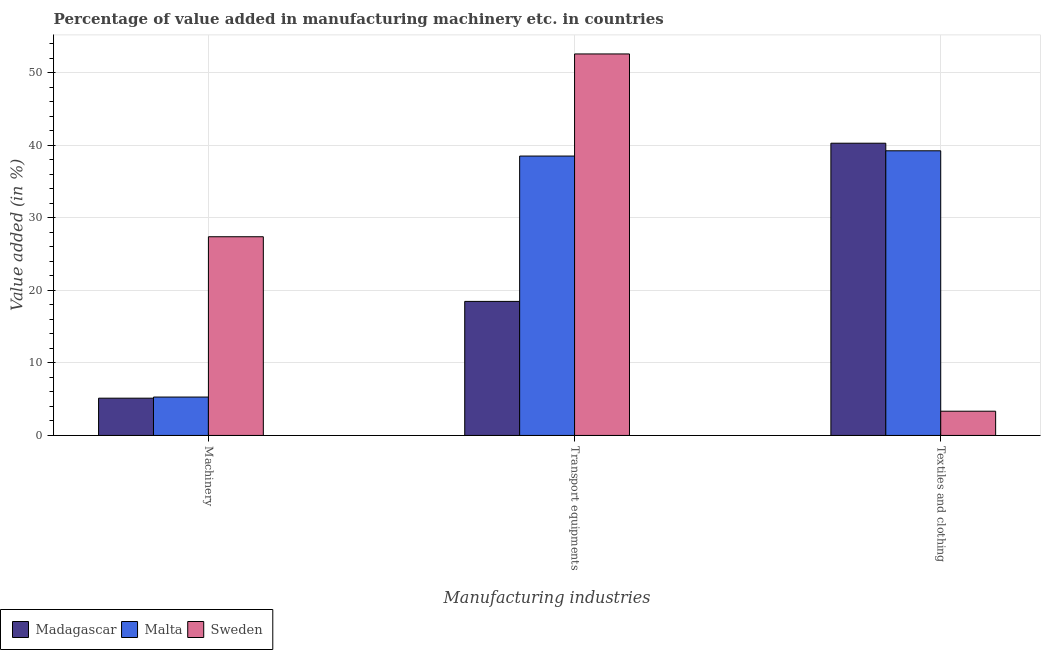How many different coloured bars are there?
Ensure brevity in your answer.  3. Are the number of bars on each tick of the X-axis equal?
Your response must be concise. Yes. How many bars are there on the 3rd tick from the left?
Give a very brief answer. 3. How many bars are there on the 3rd tick from the right?
Provide a succinct answer. 3. What is the label of the 3rd group of bars from the left?
Keep it short and to the point. Textiles and clothing. What is the value added in manufacturing transport equipments in Malta?
Provide a succinct answer. 38.49. Across all countries, what is the maximum value added in manufacturing textile and clothing?
Offer a terse response. 40.26. Across all countries, what is the minimum value added in manufacturing textile and clothing?
Your response must be concise. 3.34. In which country was the value added in manufacturing machinery minimum?
Your answer should be compact. Madagascar. What is the total value added in manufacturing transport equipments in the graph?
Your answer should be very brief. 109.52. What is the difference between the value added in manufacturing textile and clothing in Madagascar and that in Malta?
Your answer should be compact. 1.04. What is the difference between the value added in manufacturing textile and clothing in Sweden and the value added in manufacturing transport equipments in Madagascar?
Provide a succinct answer. -15.13. What is the average value added in manufacturing textile and clothing per country?
Make the answer very short. 27.61. What is the difference between the value added in manufacturing machinery and value added in manufacturing transport equipments in Sweden?
Keep it short and to the point. -25.18. In how many countries, is the value added in manufacturing textile and clothing greater than 8 %?
Your response must be concise. 2. What is the ratio of the value added in manufacturing textile and clothing in Sweden to that in Madagascar?
Keep it short and to the point. 0.08. What is the difference between the highest and the second highest value added in manufacturing machinery?
Make the answer very short. 22.09. What is the difference between the highest and the lowest value added in manufacturing machinery?
Ensure brevity in your answer.  22.24. In how many countries, is the value added in manufacturing transport equipments greater than the average value added in manufacturing transport equipments taken over all countries?
Offer a very short reply. 2. Is the sum of the value added in manufacturing machinery in Sweden and Malta greater than the maximum value added in manufacturing transport equipments across all countries?
Keep it short and to the point. No. What does the 2nd bar from the left in Machinery represents?
Offer a terse response. Malta. What does the 1st bar from the right in Transport equipments represents?
Provide a succinct answer. Sweden. How many bars are there?
Keep it short and to the point. 9. Are all the bars in the graph horizontal?
Give a very brief answer. No. How many countries are there in the graph?
Make the answer very short. 3. Are the values on the major ticks of Y-axis written in scientific E-notation?
Ensure brevity in your answer.  No. Does the graph contain any zero values?
Offer a terse response. No. Does the graph contain grids?
Make the answer very short. Yes. How many legend labels are there?
Your response must be concise. 3. What is the title of the graph?
Make the answer very short. Percentage of value added in manufacturing machinery etc. in countries. Does "Belarus" appear as one of the legend labels in the graph?
Your answer should be compact. No. What is the label or title of the X-axis?
Give a very brief answer. Manufacturing industries. What is the label or title of the Y-axis?
Make the answer very short. Value added (in %). What is the Value added (in %) in Madagascar in Machinery?
Your response must be concise. 5.13. What is the Value added (in %) of Malta in Machinery?
Offer a very short reply. 5.29. What is the Value added (in %) in Sweden in Machinery?
Offer a very short reply. 27.38. What is the Value added (in %) in Madagascar in Transport equipments?
Keep it short and to the point. 18.47. What is the Value added (in %) of Malta in Transport equipments?
Your answer should be compact. 38.49. What is the Value added (in %) of Sweden in Transport equipments?
Offer a terse response. 52.56. What is the Value added (in %) in Madagascar in Textiles and clothing?
Your answer should be compact. 40.26. What is the Value added (in %) in Malta in Textiles and clothing?
Ensure brevity in your answer.  39.22. What is the Value added (in %) in Sweden in Textiles and clothing?
Ensure brevity in your answer.  3.34. Across all Manufacturing industries, what is the maximum Value added (in %) in Madagascar?
Make the answer very short. 40.26. Across all Manufacturing industries, what is the maximum Value added (in %) in Malta?
Your answer should be very brief. 39.22. Across all Manufacturing industries, what is the maximum Value added (in %) in Sweden?
Give a very brief answer. 52.56. Across all Manufacturing industries, what is the minimum Value added (in %) in Madagascar?
Provide a succinct answer. 5.13. Across all Manufacturing industries, what is the minimum Value added (in %) in Malta?
Make the answer very short. 5.29. Across all Manufacturing industries, what is the minimum Value added (in %) of Sweden?
Offer a terse response. 3.34. What is the total Value added (in %) in Madagascar in the graph?
Provide a succinct answer. 63.86. What is the total Value added (in %) of Malta in the graph?
Offer a terse response. 83. What is the total Value added (in %) of Sweden in the graph?
Give a very brief answer. 83.27. What is the difference between the Value added (in %) of Madagascar in Machinery and that in Transport equipments?
Make the answer very short. -13.33. What is the difference between the Value added (in %) of Malta in Machinery and that in Transport equipments?
Provide a short and direct response. -33.2. What is the difference between the Value added (in %) in Sweden in Machinery and that in Transport equipments?
Your answer should be compact. -25.18. What is the difference between the Value added (in %) in Madagascar in Machinery and that in Textiles and clothing?
Provide a short and direct response. -35.13. What is the difference between the Value added (in %) of Malta in Machinery and that in Textiles and clothing?
Your response must be concise. -33.93. What is the difference between the Value added (in %) of Sweden in Machinery and that in Textiles and clothing?
Keep it short and to the point. 24.04. What is the difference between the Value added (in %) in Madagascar in Transport equipments and that in Textiles and clothing?
Make the answer very short. -21.79. What is the difference between the Value added (in %) in Malta in Transport equipments and that in Textiles and clothing?
Your answer should be compact. -0.73. What is the difference between the Value added (in %) in Sweden in Transport equipments and that in Textiles and clothing?
Give a very brief answer. 49.22. What is the difference between the Value added (in %) in Madagascar in Machinery and the Value added (in %) in Malta in Transport equipments?
Give a very brief answer. -33.36. What is the difference between the Value added (in %) in Madagascar in Machinery and the Value added (in %) in Sweden in Transport equipments?
Provide a succinct answer. -47.43. What is the difference between the Value added (in %) of Malta in Machinery and the Value added (in %) of Sweden in Transport equipments?
Give a very brief answer. -47.27. What is the difference between the Value added (in %) in Madagascar in Machinery and the Value added (in %) in Malta in Textiles and clothing?
Provide a succinct answer. -34.09. What is the difference between the Value added (in %) of Madagascar in Machinery and the Value added (in %) of Sweden in Textiles and clothing?
Ensure brevity in your answer.  1.8. What is the difference between the Value added (in %) in Malta in Machinery and the Value added (in %) in Sweden in Textiles and clothing?
Offer a terse response. 1.95. What is the difference between the Value added (in %) of Madagascar in Transport equipments and the Value added (in %) of Malta in Textiles and clothing?
Make the answer very short. -20.75. What is the difference between the Value added (in %) in Madagascar in Transport equipments and the Value added (in %) in Sweden in Textiles and clothing?
Your answer should be very brief. 15.13. What is the difference between the Value added (in %) of Malta in Transport equipments and the Value added (in %) of Sweden in Textiles and clothing?
Offer a very short reply. 35.15. What is the average Value added (in %) in Madagascar per Manufacturing industries?
Your answer should be very brief. 21.29. What is the average Value added (in %) of Malta per Manufacturing industries?
Provide a succinct answer. 27.67. What is the average Value added (in %) of Sweden per Manufacturing industries?
Offer a terse response. 27.76. What is the difference between the Value added (in %) in Madagascar and Value added (in %) in Malta in Machinery?
Make the answer very short. -0.16. What is the difference between the Value added (in %) of Madagascar and Value added (in %) of Sweden in Machinery?
Provide a short and direct response. -22.24. What is the difference between the Value added (in %) in Malta and Value added (in %) in Sweden in Machinery?
Ensure brevity in your answer.  -22.09. What is the difference between the Value added (in %) of Madagascar and Value added (in %) of Malta in Transport equipments?
Keep it short and to the point. -20.02. What is the difference between the Value added (in %) of Madagascar and Value added (in %) of Sweden in Transport equipments?
Make the answer very short. -34.09. What is the difference between the Value added (in %) of Malta and Value added (in %) of Sweden in Transport equipments?
Offer a terse response. -14.07. What is the difference between the Value added (in %) of Madagascar and Value added (in %) of Malta in Textiles and clothing?
Make the answer very short. 1.04. What is the difference between the Value added (in %) in Madagascar and Value added (in %) in Sweden in Textiles and clothing?
Make the answer very short. 36.92. What is the difference between the Value added (in %) of Malta and Value added (in %) of Sweden in Textiles and clothing?
Your answer should be compact. 35.88. What is the ratio of the Value added (in %) in Madagascar in Machinery to that in Transport equipments?
Ensure brevity in your answer.  0.28. What is the ratio of the Value added (in %) in Malta in Machinery to that in Transport equipments?
Give a very brief answer. 0.14. What is the ratio of the Value added (in %) of Sweden in Machinery to that in Transport equipments?
Make the answer very short. 0.52. What is the ratio of the Value added (in %) in Madagascar in Machinery to that in Textiles and clothing?
Provide a succinct answer. 0.13. What is the ratio of the Value added (in %) in Malta in Machinery to that in Textiles and clothing?
Provide a short and direct response. 0.13. What is the ratio of the Value added (in %) in Sweden in Machinery to that in Textiles and clothing?
Your answer should be compact. 8.2. What is the ratio of the Value added (in %) of Madagascar in Transport equipments to that in Textiles and clothing?
Your answer should be compact. 0.46. What is the ratio of the Value added (in %) in Malta in Transport equipments to that in Textiles and clothing?
Provide a short and direct response. 0.98. What is the ratio of the Value added (in %) in Sweden in Transport equipments to that in Textiles and clothing?
Make the answer very short. 15.75. What is the difference between the highest and the second highest Value added (in %) of Madagascar?
Your answer should be compact. 21.79. What is the difference between the highest and the second highest Value added (in %) of Malta?
Your response must be concise. 0.73. What is the difference between the highest and the second highest Value added (in %) of Sweden?
Your answer should be very brief. 25.18. What is the difference between the highest and the lowest Value added (in %) of Madagascar?
Offer a very short reply. 35.13. What is the difference between the highest and the lowest Value added (in %) in Malta?
Offer a very short reply. 33.93. What is the difference between the highest and the lowest Value added (in %) of Sweden?
Offer a terse response. 49.22. 